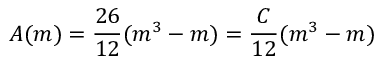<formula> <loc_0><loc_0><loc_500><loc_500>A ( m ) = \frac { 2 6 } { 1 2 } ( m ^ { 3 } - m ) = \frac { C } { 1 2 } ( m ^ { 3 } - m )</formula> 